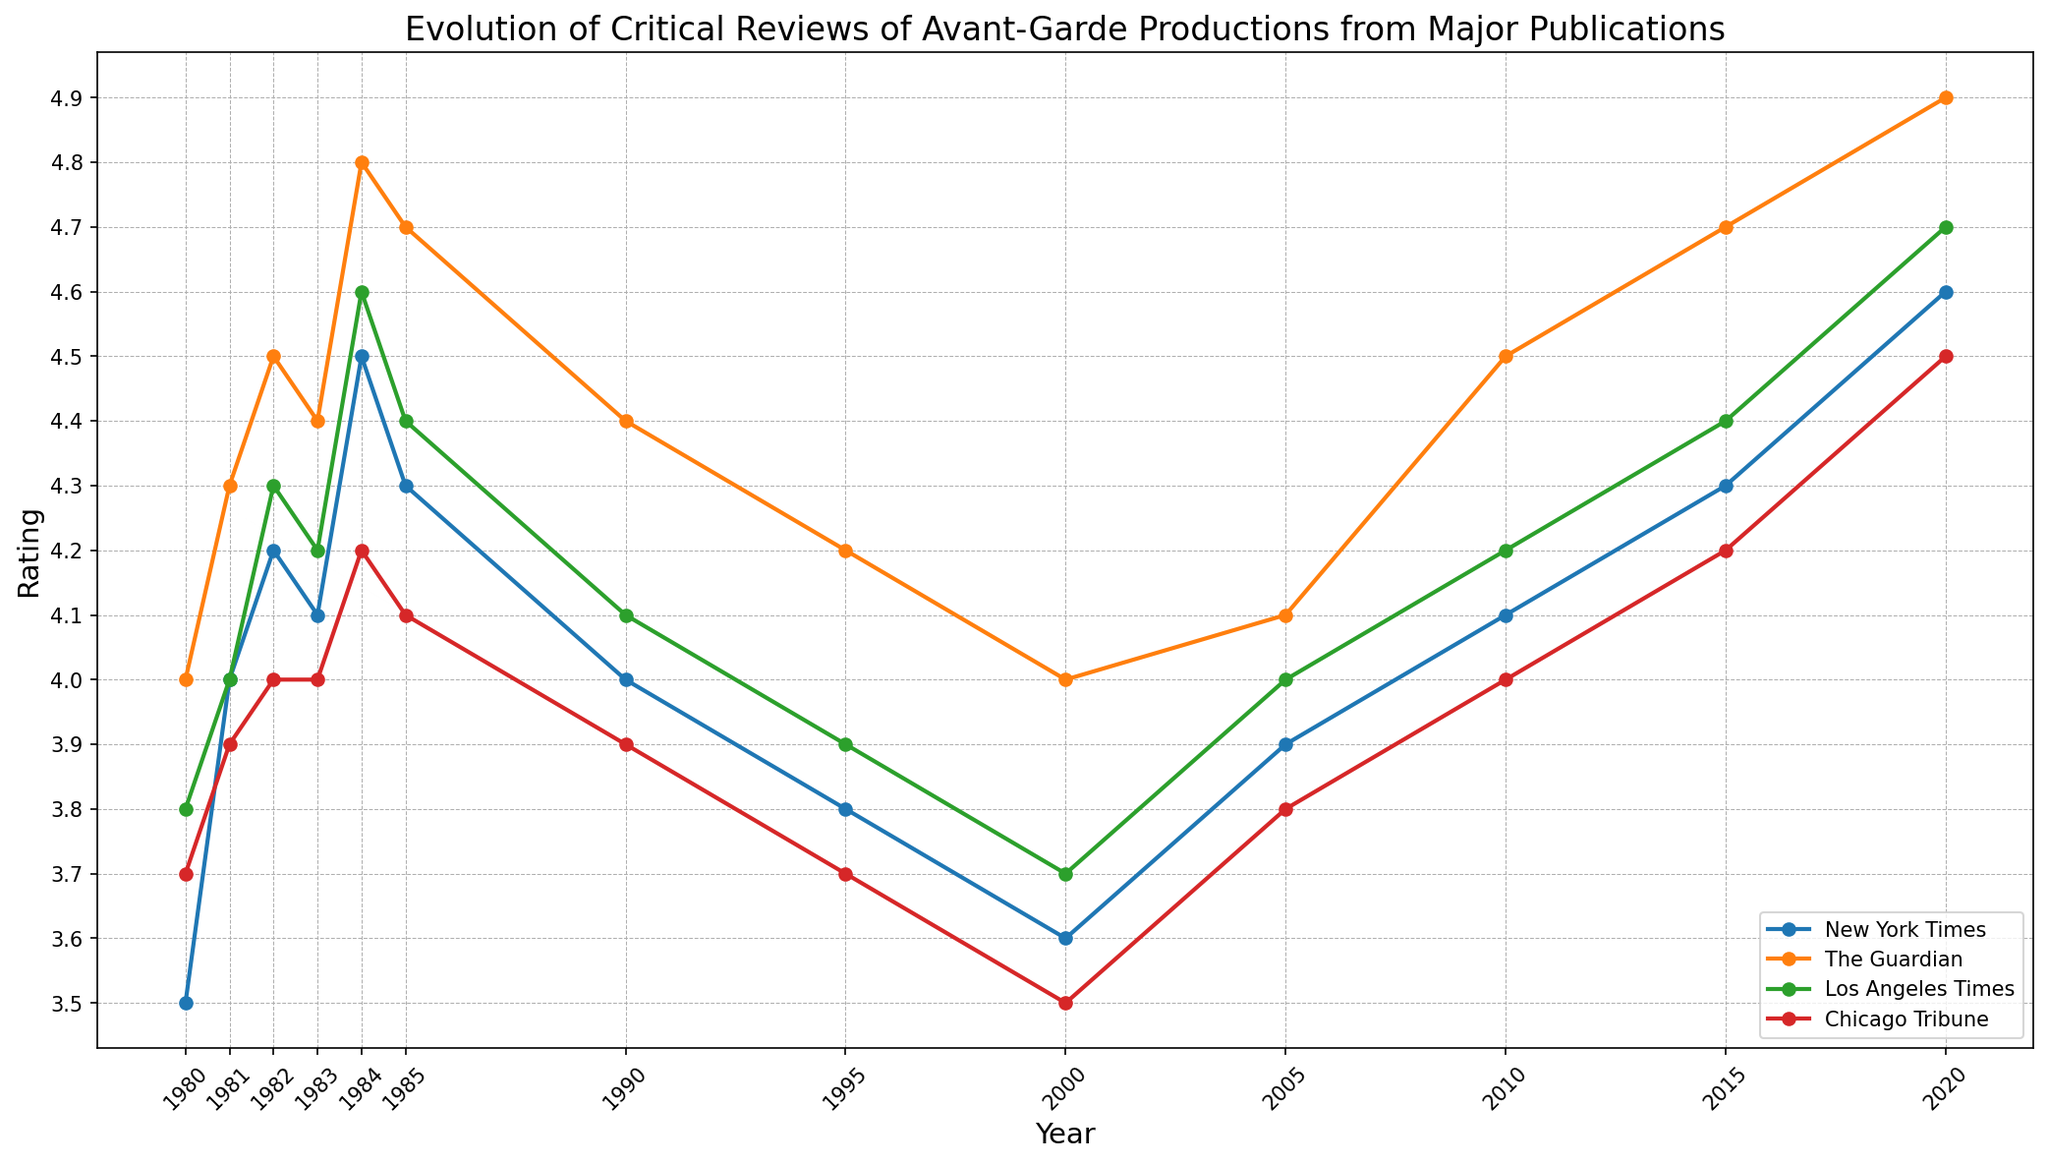Which publication has the highest rating in 2020? To find the highest rating in 2020, inspect the plot and identify the rating values for each publication in 2020. The Guardian has the highest rating at 4.9.
Answer: The Guardian How did the ratings of the New York Times change from 1980 to 2020? To analyze the change, compare the ratings at the beginning (1980) and end (2020). In 1980, the rating was 3.5. By 2020, it increased to 4.6. So, the New York Times' rating increased by 1.1 points.
Answer: Increased by 1.1 Which publication showed the most consistent rating over the years? To determine consistency, check for the publication with the least fluctuations in rating. Chicago Tribune's ratings show the smallest changes over the years, hovering around 4.0.
Answer: Chicago Tribune What is the average rating of The Guardian from 1980 to 2020? To find the average rating, sum The Guardian's ratings over the years and divide by the number of data points (1980 to 2020). The sum of The Guardian's ratings is (4.0+4.3+4.5+4.4+4.8+4.7+4.4+4.2+4.0+4.1+4.5+4.7+4.9) = 57.5, for 13 years, the average is 57.5 / 13.
Answer: 4.42 Between which consecutive years did the Los Angeles Times experience the largest drop in rating? Identify the largest drop by comparing the ratings for consecutive years. From 1984 (4.6) to 1985 (4.4) is the largest drop of 0.2 points.
Answer: 1984 to 1985 Which publication had the highest increase in rating from 2015 to 2020? Compare the ratings for each publication between 2015 and 2020. The Guardian's rating increased from 4.7 to 4.9, the highest increase of 0.2 points.
Answer: The Guardian Which year showed the smallest average rating across all publications? Calculate the average rating for each year by summing the ratings for all publications and dividing by the number of publications. For 2000, (3.6+4.0+3.7+3.5) = 14.8, with 4 publications, the average is 3.7, the smallest average of all years.
Answer: 2000 Did any publication's rating decline between 1980 and 1995? Check the start and end ratings for each publication between the years 1980 and 1995. Both New York Times and Chicago Tribune show declines from 3.5 to 3.8 and 3.7 to 3.7 respectively.
Answer: Yes (New York Times and Chicago Tribune) On average, which publication gave the highest ratings to avant-garde productions? Calculate the average rating for each publication across all years. The Guardian consistently has higher ratings averaging around 4.42, higher than other publications.
Answer: The Guardian 